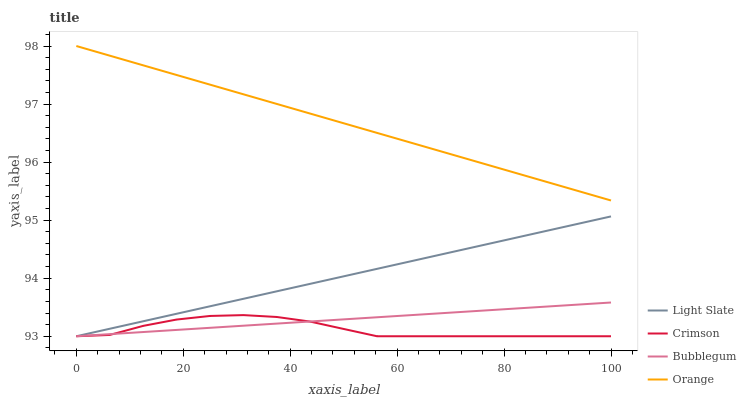Does Crimson have the minimum area under the curve?
Answer yes or no. Yes. Does Orange have the maximum area under the curve?
Answer yes or no. Yes. Does Orange have the minimum area under the curve?
Answer yes or no. No. Does Crimson have the maximum area under the curve?
Answer yes or no. No. Is Orange the smoothest?
Answer yes or no. Yes. Is Crimson the roughest?
Answer yes or no. Yes. Is Crimson the smoothest?
Answer yes or no. No. Is Orange the roughest?
Answer yes or no. No. Does Light Slate have the lowest value?
Answer yes or no. Yes. Does Orange have the lowest value?
Answer yes or no. No. Does Orange have the highest value?
Answer yes or no. Yes. Does Crimson have the highest value?
Answer yes or no. No. Is Light Slate less than Orange?
Answer yes or no. Yes. Is Orange greater than Crimson?
Answer yes or no. Yes. Does Light Slate intersect Crimson?
Answer yes or no. Yes. Is Light Slate less than Crimson?
Answer yes or no. No. Is Light Slate greater than Crimson?
Answer yes or no. No. Does Light Slate intersect Orange?
Answer yes or no. No. 